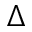Convert formula to latex. <formula><loc_0><loc_0><loc_500><loc_500>\Delta</formula> 